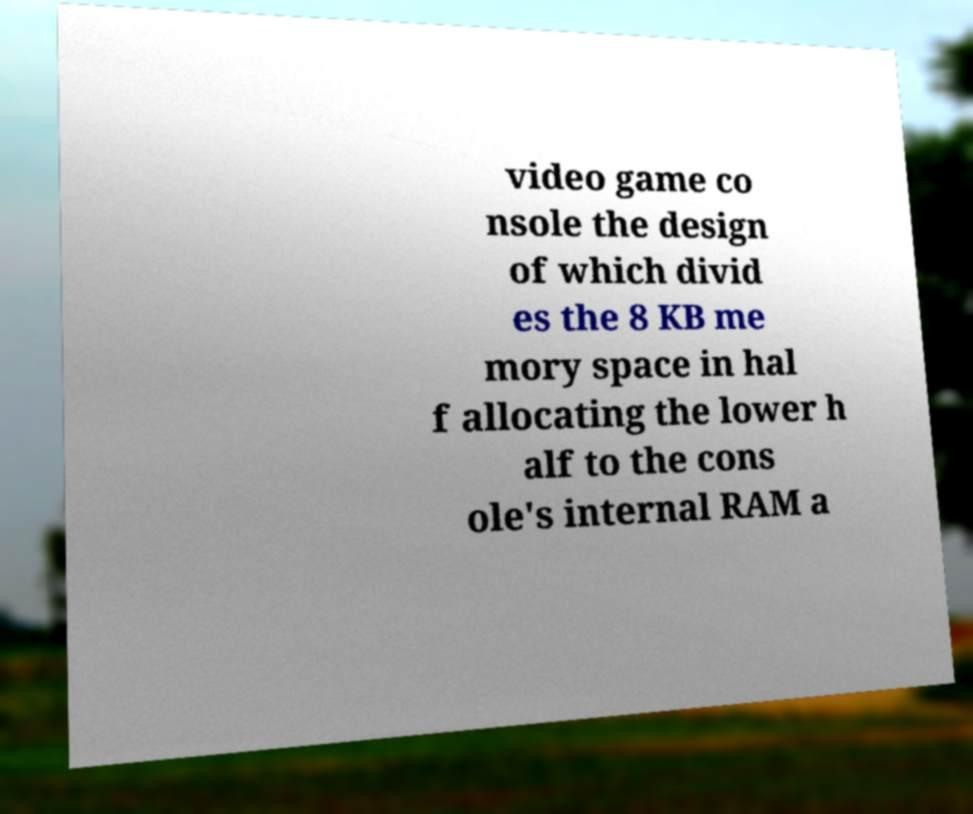What messages or text are displayed in this image? I need them in a readable, typed format. video game co nsole the design of which divid es the 8 KB me mory space in hal f allocating the lower h alf to the cons ole's internal RAM a 